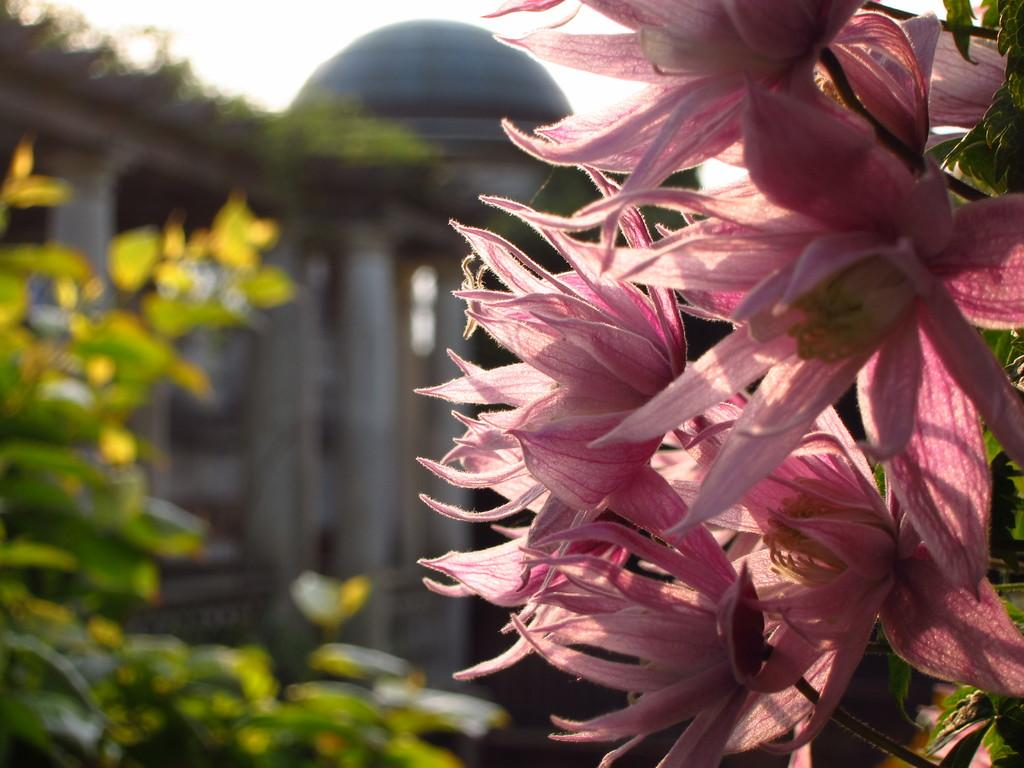What type of living organisms can be seen in the image? Flowers and plants can be seen in the image. Can you describe the background of the image? There is a building in the background of the image. How many boats can be seen in the image? There are no boats present in the image. What type of jewel is the flower wearing in the image? There are no jewels or any indication of jewelry on the flowers in the image. 